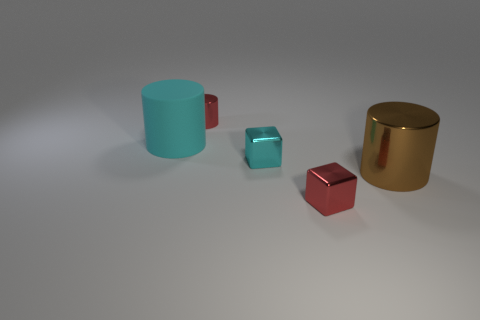Suppose this image is part of an art exhibit; what theme or message could it convey? If this image were part of an art exhibit, the theme might explore the interplay between form and material, highlighting how identical shapes can differ profoundly in their visual impact depending on their surface treatment and color, thus evoking a message about perception and individuality. 